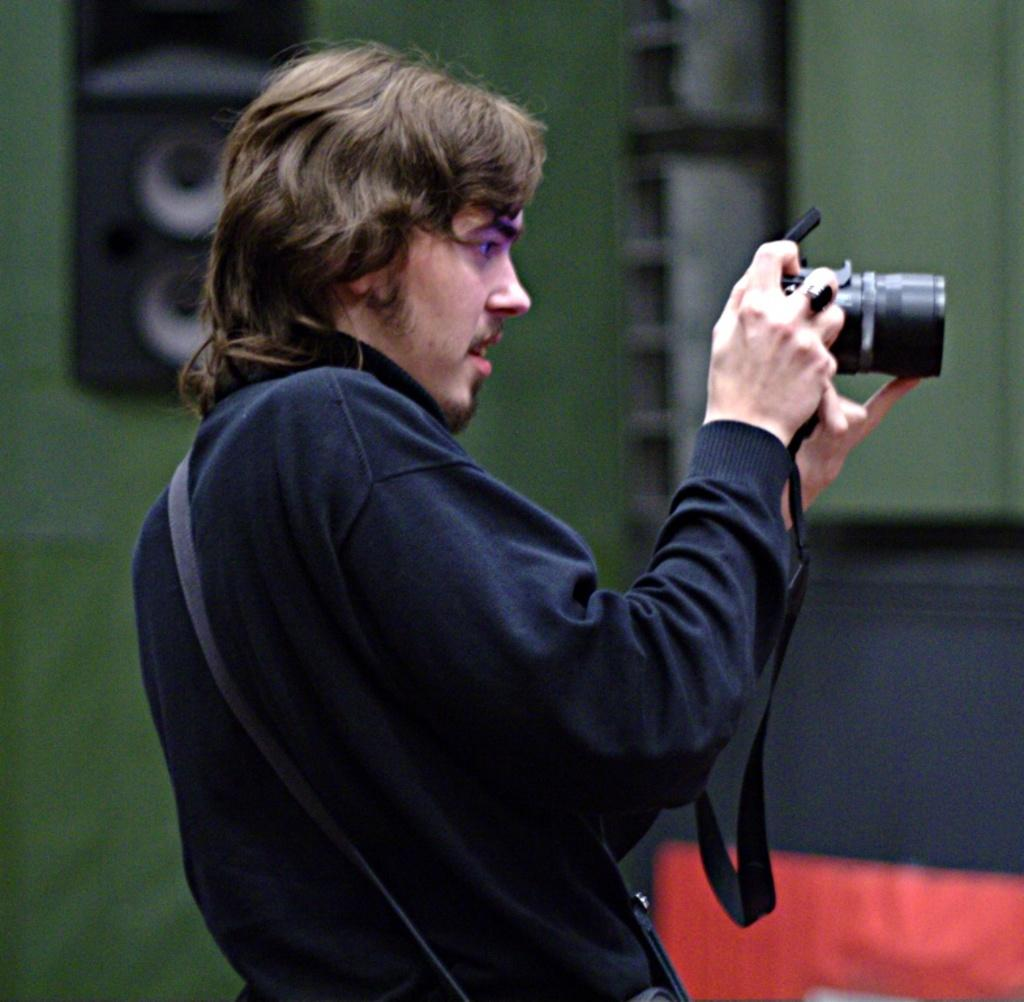What is the main subject of the image? There is a man standing in the image. What is the man wearing? The man is wearing clothes. What is the man holding in his hands? The man is holding a camera in his hands. What other object can be seen in the image? There is a sound box in the image. How would you describe the background of the image? The background of the image is blurred. What hobbies does the man have, based on the image? The image does not provide information about the man's hobbies. --- Facts: 1. There is a car in the image. 2. The car is red. 3. The car has four wheels. 4. The car is parked on the street. 5. There are people walking on the sidewalk. Absurd Topics: bicycle, parrot, ocean Conversation: What is the main subject in the image? There is a car in the image. What color is the car? The car is red. How many wheels does the car have? The car has four wheels. Where is the car located in the image? The car is parked on the street. What else can be seen in the image? There are people walking on the sidewalk. Reasoning: Let's think step by step in order to produce the conversation. We start by identifying the main subject of the image, which is the car. Then, we describe specific features of the car, such as its color and the number of wheels it has. Next, we observe the car's location in the image, which is parked on the street. Finally, we mention other elements present in the image, such as the people walking on the sidewalk. Absurd Question/Answer: Can you see a parrot sitting on the car's hood in the image? There is no parrot sitting on the car's hood in the image. --- Facts: 1. There is a dog in the image. 2. The dog is brown. 3. The dog is sitting on the grass. 4. There is a tree in the background. 5. The sky is visible in the image. Absurd Topics: piano, rainbow, concert Conversation: What type of animal can be seen in the image? There is a dog in the image. What color is the dog? The dog is brown. What is the dog doing in the image? The dog is sitting on the grass. What can be seen in the background of the image? There is a tree in the background. What part of the natural environment is visible in the image? The sky is visible in the image. Reasoning: Let's think step by step in order to produce the conversation. We start by identifying the main subject of the image, which is the dog. Then, we describe specific features of the dog 